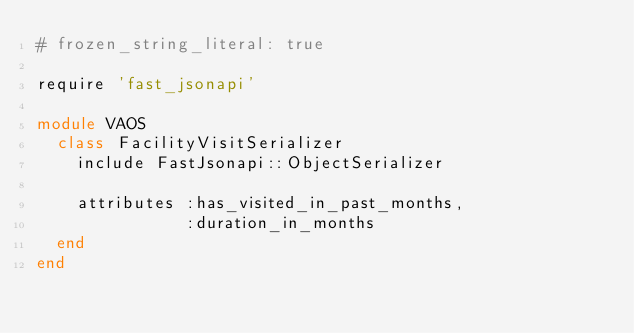<code> <loc_0><loc_0><loc_500><loc_500><_Ruby_># frozen_string_literal: true

require 'fast_jsonapi'

module VAOS
  class FacilityVisitSerializer
    include FastJsonapi::ObjectSerializer

    attributes :has_visited_in_past_months,
               :duration_in_months
  end
end
</code> 